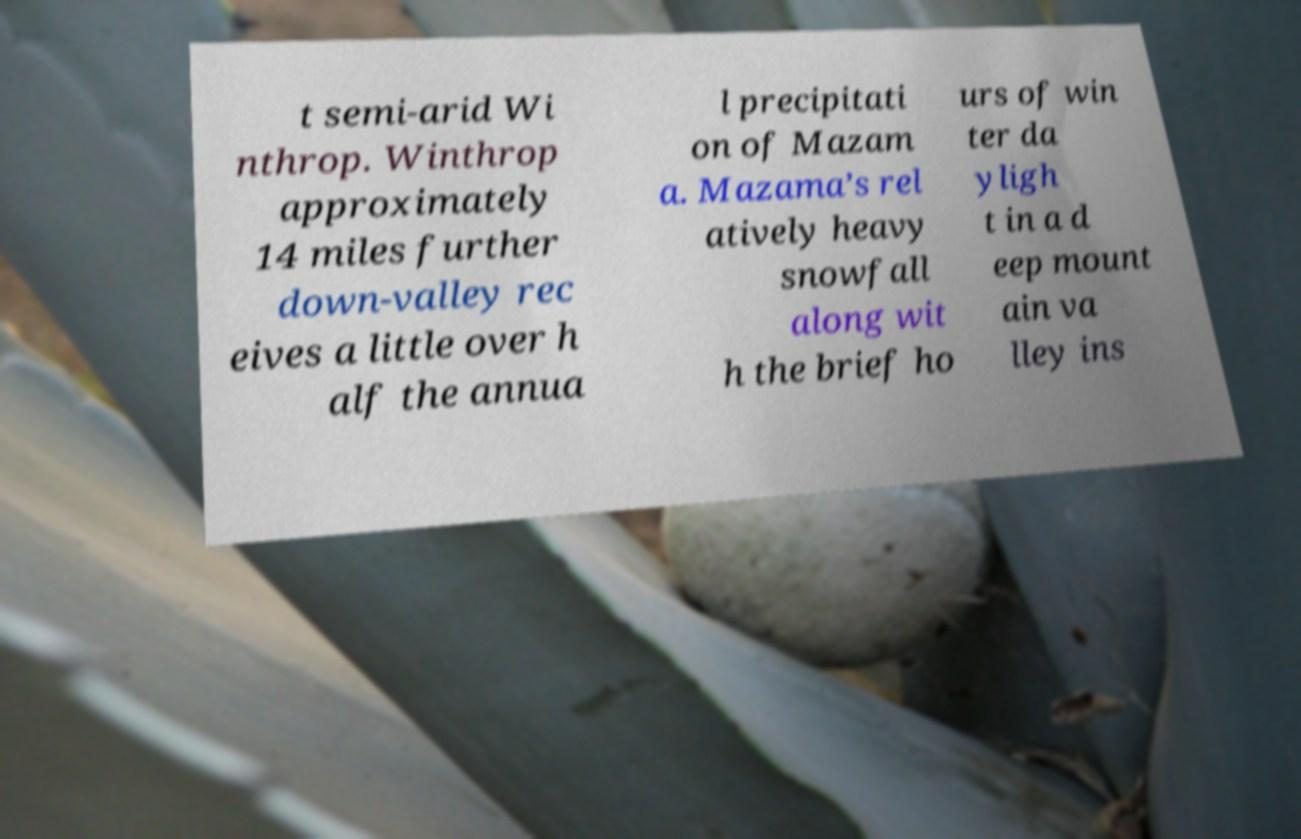Could you extract and type out the text from this image? t semi-arid Wi nthrop. Winthrop approximately 14 miles further down-valley rec eives a little over h alf the annua l precipitati on of Mazam a. Mazama’s rel atively heavy snowfall along wit h the brief ho urs of win ter da yligh t in a d eep mount ain va lley ins 